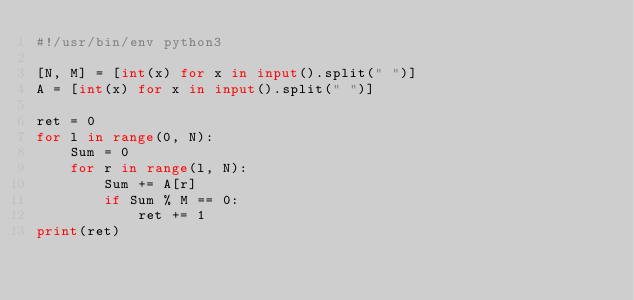Convert code to text. <code><loc_0><loc_0><loc_500><loc_500><_Python_>#!/usr/bin/env python3

[N, M] = [int(x) for x in input().split(" ")]
A = [int(x) for x in input().split(" ")]

ret = 0
for l in range(0, N):
    Sum = 0
    for r in range(l, N):
        Sum += A[r]
        if Sum % M == 0:
            ret += 1
print(ret)
</code> 